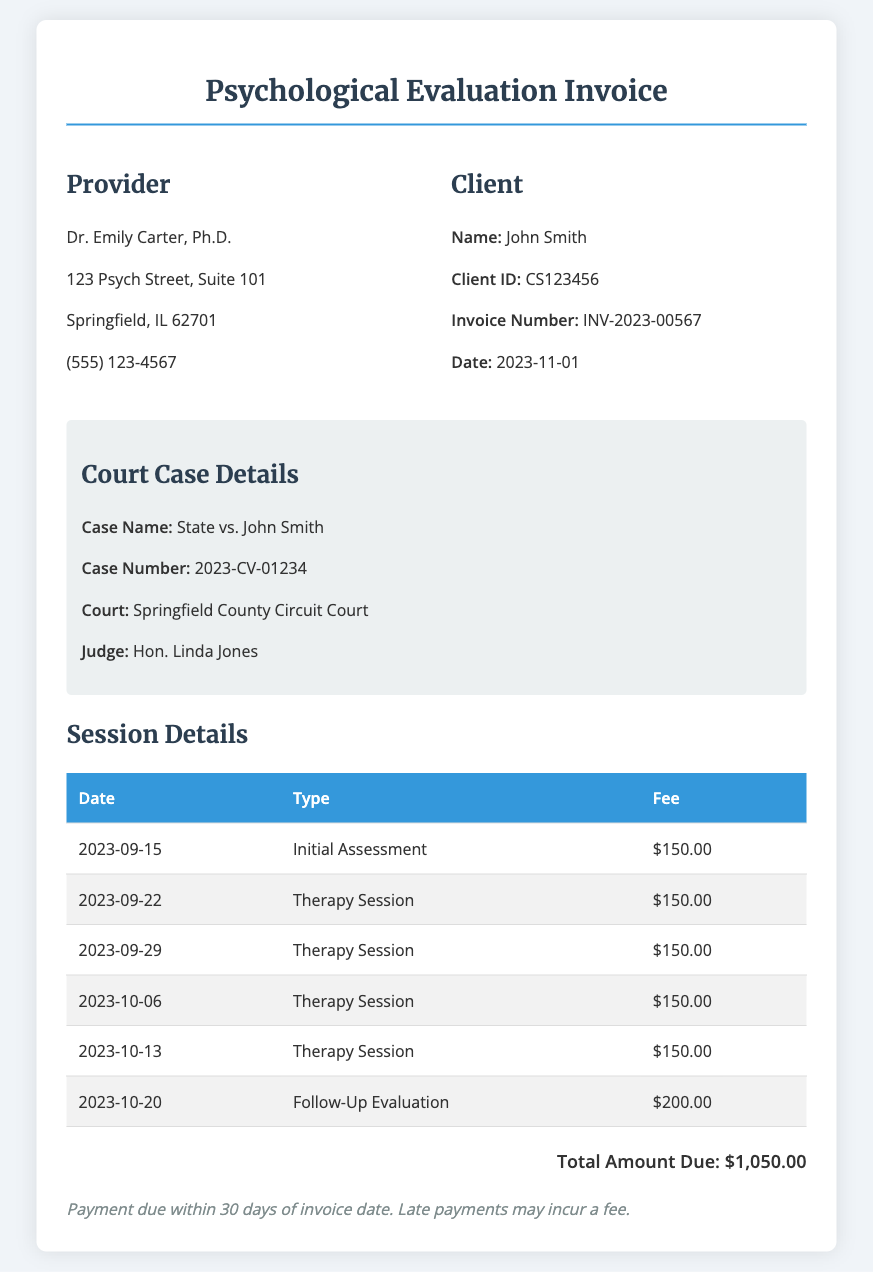What is the provider's name? The provider's name is listed in the document under the provider information section.
Answer: Dr. Emily Carter, Ph.D What is the client ID? The client ID is found next to the client's name, providing a unique identifier for the client.
Answer: CS123456 What is the invoice number? The invoice number is mentioned in the client information section, indicating the specific transaction.
Answer: INV-2023-00567 How many therapy sessions are listed? The number of therapy sessions is determined by counting the relevant entries in the session details table.
Answer: 5 What is the total amount due? The total amount due is clearly stated at the bottom of the invoice, representing the sum of all fees.
Answer: $1,050.00 What type of evaluation occurred on October 20, 2023? The type of evaluation is specified in the session details table for the corresponding date.
Answer: Follow-Up Evaluation What is the fee for an initial assessment? The fee for an initial assessment can be found in the session details table under the corresponding type.
Answer: $150.00 Who is the judge assigned to the case? The judge's name is presented in the court case details section of the document.
Answer: Hon. Linda Jones When was the invoice issued? The invoice date is indicated in the client information section and represents when the invoice was created.
Answer: 2023-11-01 